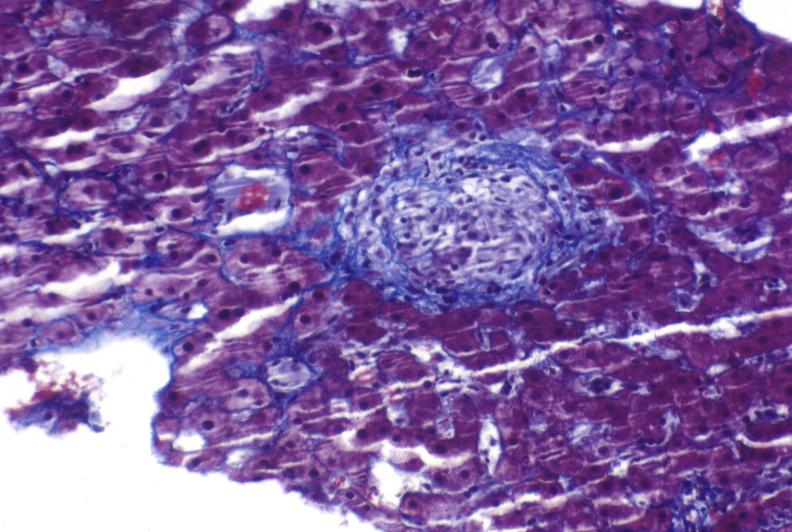does this image show sarcoid?
Answer the question using a single word or phrase. Yes 